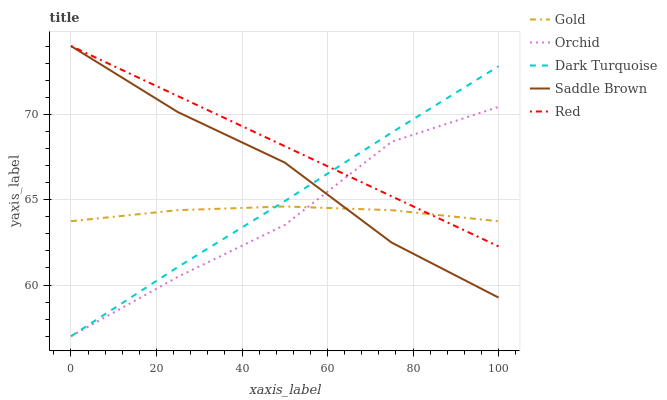Does Orchid have the minimum area under the curve?
Answer yes or no. Yes. Does Red have the maximum area under the curve?
Answer yes or no. Yes. Does Saddle Brown have the minimum area under the curve?
Answer yes or no. No. Does Saddle Brown have the maximum area under the curve?
Answer yes or no. No. Is Red the smoothest?
Answer yes or no. Yes. Is Orchid the roughest?
Answer yes or no. Yes. Is Saddle Brown the smoothest?
Answer yes or no. No. Is Saddle Brown the roughest?
Answer yes or no. No. Does Dark Turquoise have the lowest value?
Answer yes or no. Yes. Does Red have the lowest value?
Answer yes or no. No. Does Saddle Brown have the highest value?
Answer yes or no. Yes. Does Gold have the highest value?
Answer yes or no. No. Does Orchid intersect Saddle Brown?
Answer yes or no. Yes. Is Orchid less than Saddle Brown?
Answer yes or no. No. Is Orchid greater than Saddle Brown?
Answer yes or no. No. 